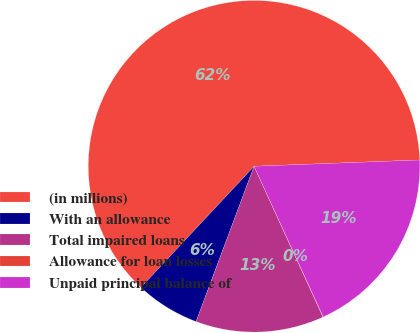<chart> <loc_0><loc_0><loc_500><loc_500><pie_chart><fcel>(in millions)<fcel>With an allowance<fcel>Total impaired loans<fcel>Allowance for loan losses<fcel>Unpaid principal balance of<nl><fcel>62.43%<fcel>6.27%<fcel>12.51%<fcel>0.03%<fcel>18.75%<nl></chart> 